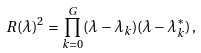<formula> <loc_0><loc_0><loc_500><loc_500>R ( \lambda ) ^ { 2 } = \prod _ { k = 0 } ^ { G } ( \lambda - \lambda _ { k } ) ( \lambda - \lambda _ { k } ^ { * } ) \, ,</formula> 